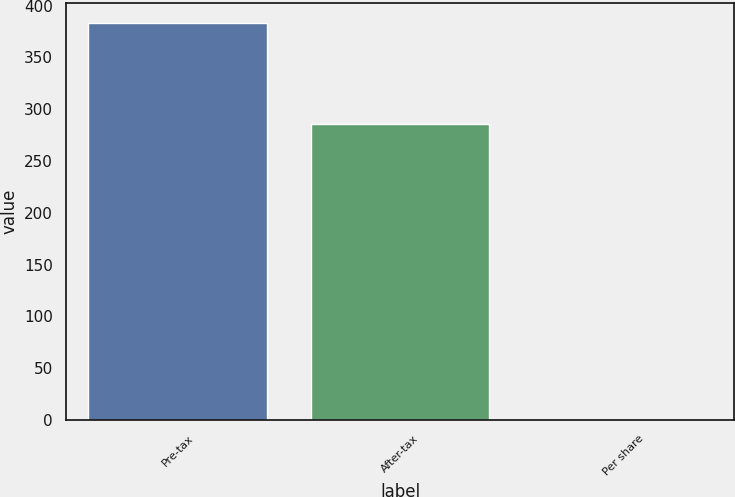Convert chart to OTSL. <chart><loc_0><loc_0><loc_500><loc_500><bar_chart><fcel>Pre-tax<fcel>After-tax<fcel>Per share<nl><fcel>383<fcel>286<fcel>0.18<nl></chart> 